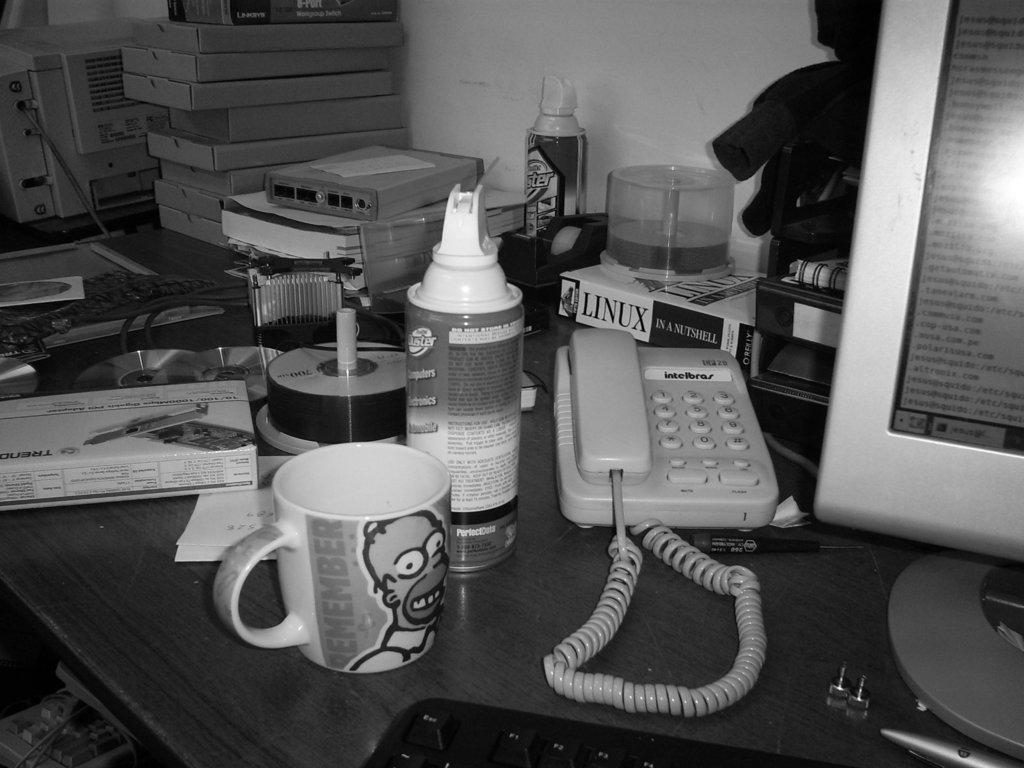What is the main piece of furniture in the image? There is a table in the image. What objects are placed on the table? A telephone, a monitor, a bottle, a cup, and some DVDs are placed on the table. Can you describe the background of the image? There are boxes in the background of the image near the wall. Can you tell me how many frogs are sitting on the island in the image? There is no island or frogs present in the image. What type of hospital can be seen in the background of the image? There is no hospital visible in the image; it features a table with various objects and boxes in the background. 